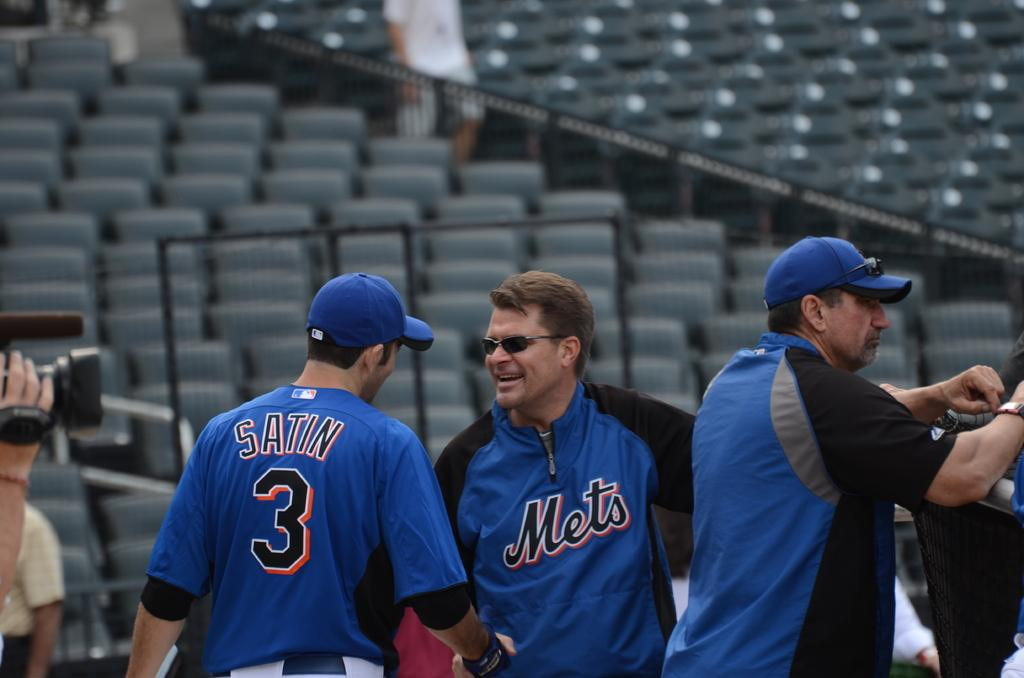<image>
Present a compact description of the photo's key features. a few people that are wearing Mets outfits 